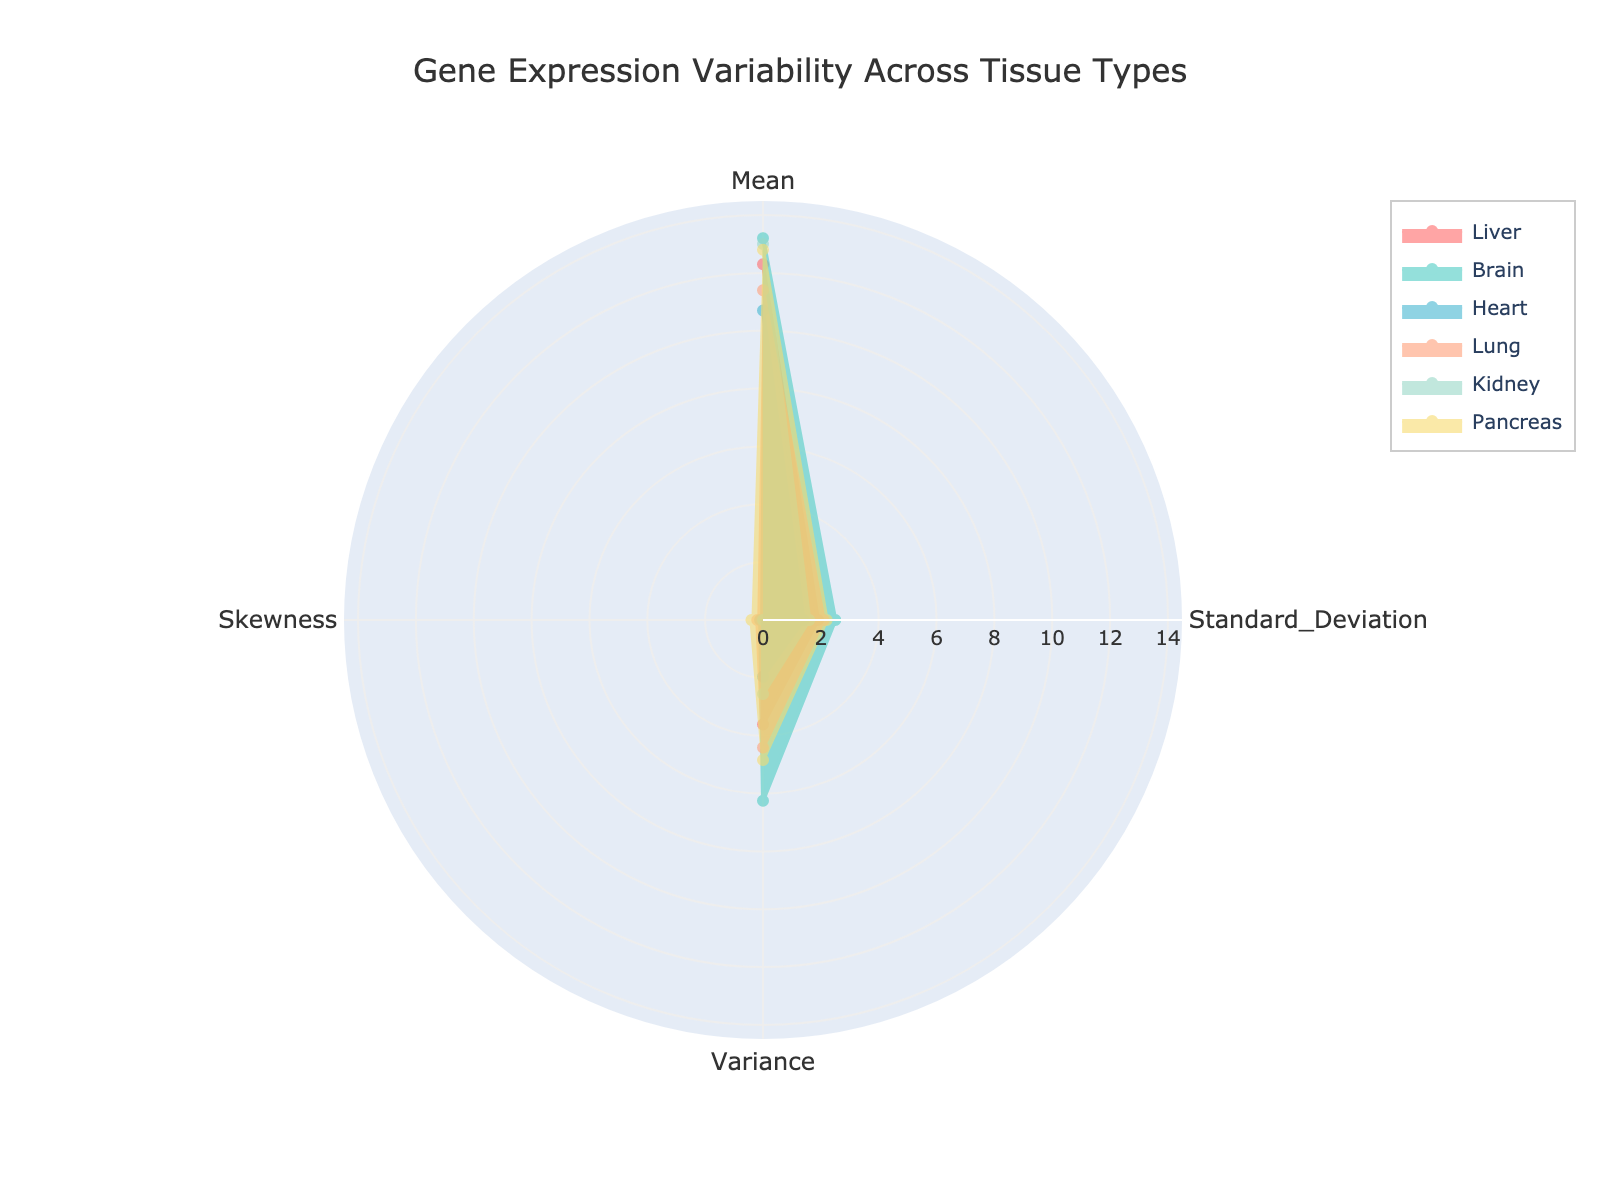Which tissue type has the highest mean gene expression? Looking at the figure, the highest mean gene expression can be identified as the tissue type with the largest radius value in the "Mean" axis.
Answer: Brain Which tissue type has the lowest standard deviation in gene expression? Locate the "Standard Deviation" axis and find the smallest radius value, which corresponds to the tissue type with the lowest standard deviation.
Answer: Heart What is the variance of gene expression for the Lung tissue? The variance can be read directly from the "Variance" axis for the Lung tissue, denoted by its respective radius value on that axis.
Answer: 4.41 Which tissue types have a negative skewness in their gene expression data? From the "Skewness" axis, identify the tissue types that fall below zero on this axis, indicating negative skewness.
Answer: Liver, Heart How do the mean gene expressions compare between the Kidney and Liver tissues? On the "Mean" axis, compare the radius values for the Kidney and Liver tissues. The Liver has a mean of 12.3 while the Kidney has a mean of 13.0, thus Kidney has a higher mean than Liver.
Answer: Kidney is higher Calculate the average variance of gene expression across all tissue types. Sum the variances for all tissue types and then divide by the number of tissues (6). Sum = 3.61 + 6.25 + 1.96 + 4.41 + 2.56 + 4.84 = 23.63. Average = 23.63 / 6 = 3.94
Answer: 3.94 Which tissue type has the closest mean gene expression to the average mean of all tissue types? First, calculate the average mean: (12.3 + 13.2 + 10.7 + 11.4 + 13.0 + 12.8) / 6 = 12.23. Then identify the tissue whose mean is nearest to 12.23 on the "Mean" axis.
Answer: Liver Which tissue type exhibits the greatest variability in gene expression? The greatest variability corresponds to the highest variance value. Locate the highest point on the "Variance" axis.
Answer: Brain How does the skewness of the Pancreas tissue compare to that of the Lung tissue? Compare the radius values on the "Skewness" axis for both Pancreas and Lung tissues. Pancreas has a skewness of 0.4, and Lung has a skewness of 0.2, so Pancreas is greater.
Answer: Pancreas is greater Which tissue type has the least variability in terms of variance? The least variability corresponds to the lowest value on the "Variance" axis.
Answer: Heart 